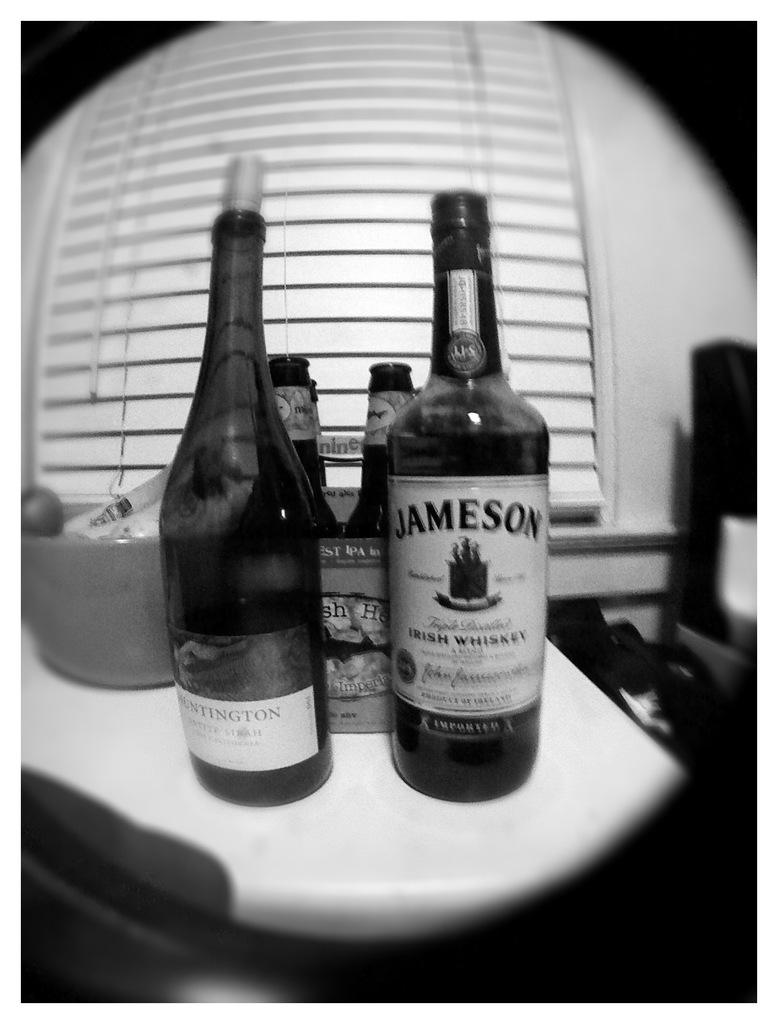What is the color scheme of the image? The picture is black and white. What objects can be seen on the table in the image? There are wine bottles on a table in the image. What other item is present on the table besides the wine bottles? There is a bowl with unspecified contents in the image. How many deer are visible in the image? There are no deer present in the image. What type of support system is in place for the wine bottles in the image? The image does not show any specific support system for the wine bottles; they are simply placed on the table. 